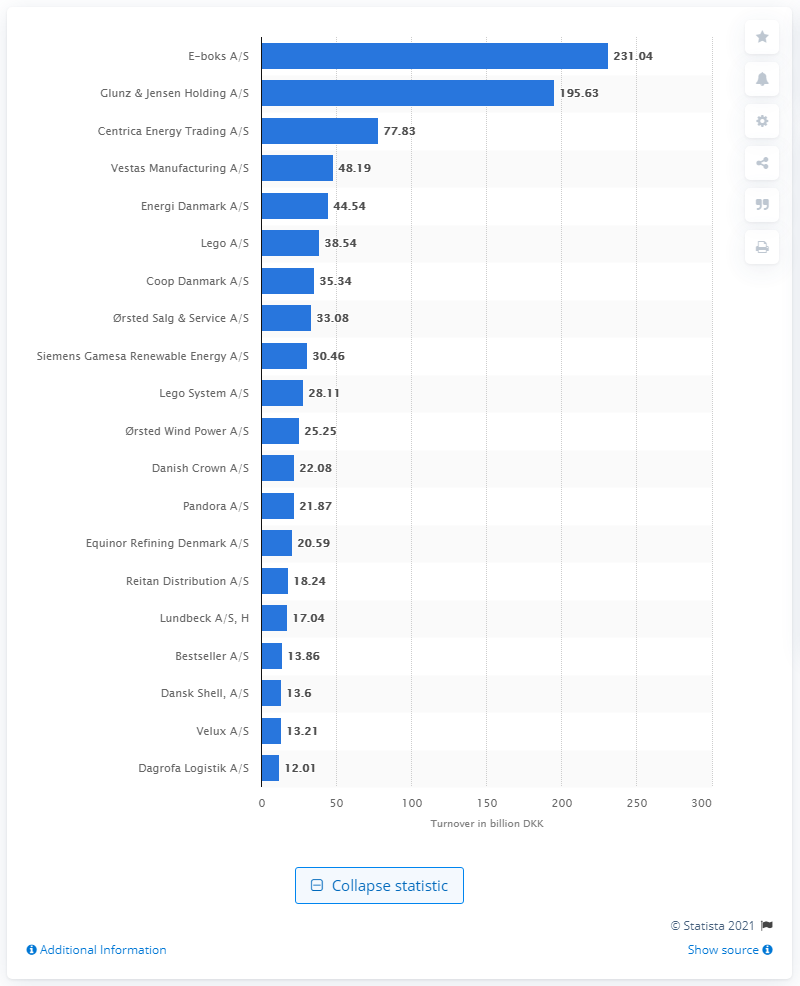Mention a couple of crucial points in this snapshot. Glunz & Jensen Holding A/S is the leading prepress company in Denmark. Centrica Energy Trading A/S ranked third in terms of revenue in Denmark. 